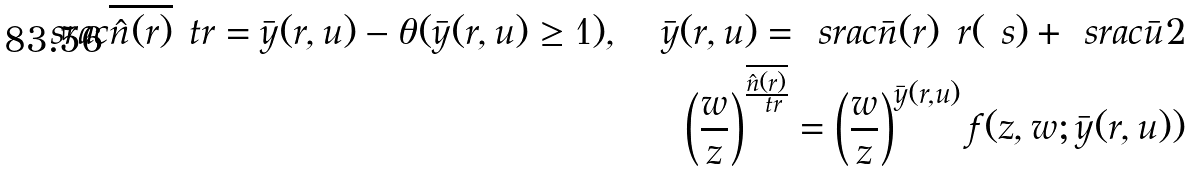<formula> <loc_0><loc_0><loc_500><loc_500>\ s r a c { \overline { \hat { n } ( r ) } } { \ t r } = \bar { y } ( r , u ) - \theta ( \bar { y } ( r , u ) \geq 1 ) , \quad \bar { y } ( r , u ) = \ s r a c { \bar { n } ( r ) } { \ r ( \ s ) } + \ s r a c { \bar { u } } { 2 } \\ \left ( \frac { w } { z } \right ) ^ { \frac { \overline { \hat { n } ( r ) } } { \ t r } } = \left ( \frac { w } { z } \right ) ^ { \bar { y } ( r , u ) } f ( z , w ; \bar { y } ( r , u ) )</formula> 